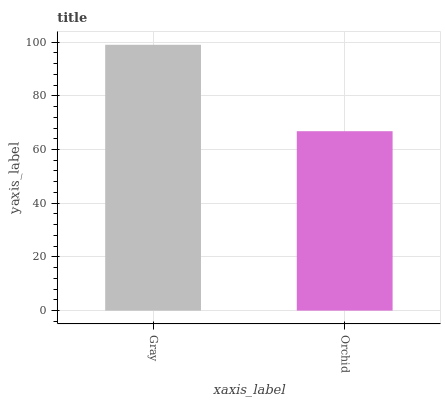Is Orchid the minimum?
Answer yes or no. Yes. Is Gray the maximum?
Answer yes or no. Yes. Is Orchid the maximum?
Answer yes or no. No. Is Gray greater than Orchid?
Answer yes or no. Yes. Is Orchid less than Gray?
Answer yes or no. Yes. Is Orchid greater than Gray?
Answer yes or no. No. Is Gray less than Orchid?
Answer yes or no. No. Is Gray the high median?
Answer yes or no. Yes. Is Orchid the low median?
Answer yes or no. Yes. Is Orchid the high median?
Answer yes or no. No. Is Gray the low median?
Answer yes or no. No. 